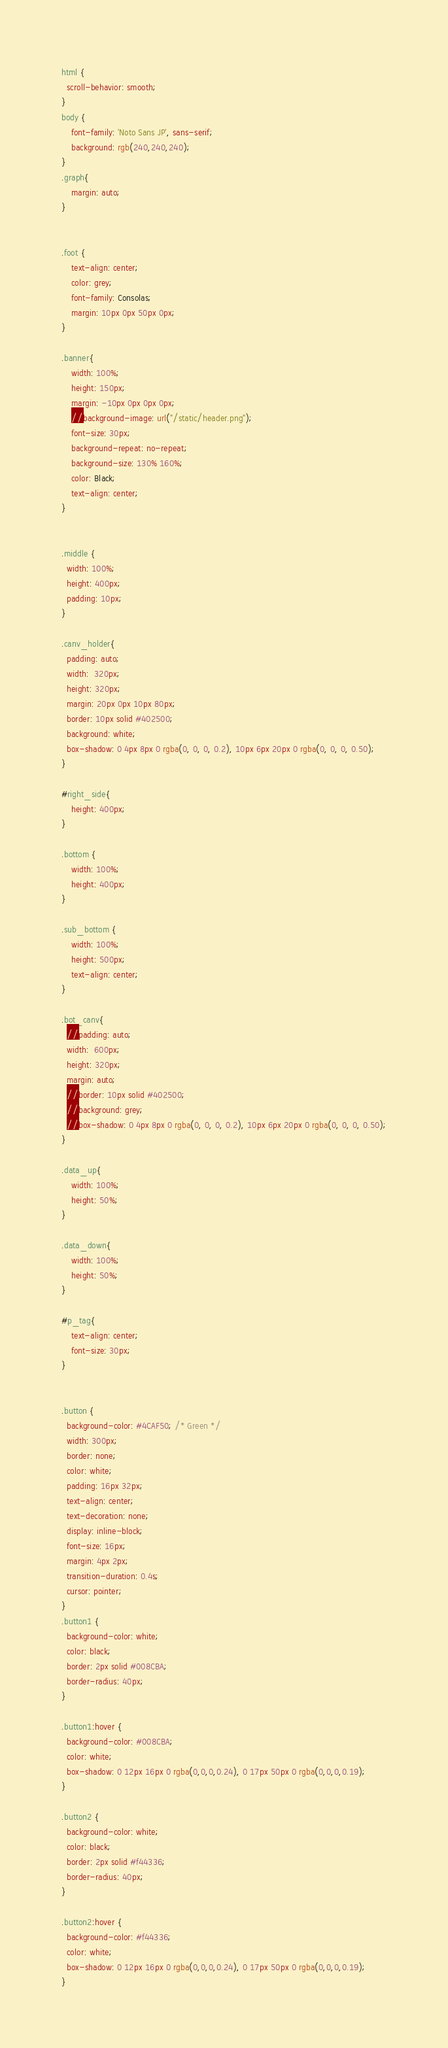<code> <loc_0><loc_0><loc_500><loc_500><_CSS_>html {
  scroll-behavior: smooth;
}
body {
    font-family: 'Noto Sans JP', sans-serif;
    background: rgb(240,240,240);
}
.graph{
    margin: auto;
}


.foot {
	text-align: center;
	color: grey;
	font-family: Consolas;
	margin: 10px 0px 50px 0px;
}

.banner{
    width: 100%;
    height: 150px;
    margin: -10px 0px 0px 0px;
    //background-image: url("/static/header.png");
    font-size: 30px;
    background-repeat: no-repeat;
    background-size: 130% 160%;
    color: Black;
    text-align: center;
}


.middle {
  width: 100%;
  height: 400px;
  padding: 10px;
}

.canv_holder{
  padding: auto;
  width:  320px;
  height: 320px;
  margin: 20px 0px 10px 80px;
  border: 10px solid #402500;
  background: white;
  box-shadow: 0 4px 8px 0 rgba(0, 0, 0, 0.2), 10px 6px 20px 0 rgba(0, 0, 0, 0.50);
}

#right_side{
    height: 400px;
}

.bottom {
	width: 100%;
	height: 400px;
}

.sub_bottom {
	width: 100%;
	height: 500px;
	text-align: center;
}

.bot_canv{
  //padding: auto;
  width:  600px;
  height: 320px;
  margin: auto;
  //border: 10px solid #402500;
  //background: grey;
  //box-shadow: 0 4px 8px 0 rgba(0, 0, 0, 0.2), 10px 6px 20px 0 rgba(0, 0, 0, 0.50);
}

.data_up{
    width: 100%;
    height: 50%;
}

.data_down{
    width: 100%;
    height: 50%;
}

#p_tag{
    text-align: center;
    font-size: 30px;
}


.button {
  background-color: #4CAF50; /* Green */
  width: 300px;
  border: none;
  color: white;
  padding: 16px 32px;
  text-align: center;
  text-decoration: none;
  display: inline-block;
  font-size: 16px;
  margin: 4px 2px;
  transition-duration: 0.4s;
  cursor: pointer;
}
.button1 {
  background-color: white;
  color: black;
  border: 2px solid #008CBA;
  border-radius: 40px;
}

.button1:hover {
  background-color: #008CBA;
  color: white;
  box-shadow: 0 12px 16px 0 rgba(0,0,0,0.24), 0 17px 50px 0 rgba(0,0,0,0.19);
}

.button2 {
  background-color: white;
  color: black;
  border: 2px solid #f44336;
  border-radius: 40px;
}

.button2:hover {
  background-color: #f44336;
  color: white;
  box-shadow: 0 12px 16px 0 rgba(0,0,0,0.24), 0 17px 50px 0 rgba(0,0,0,0.19);
}
</code> 